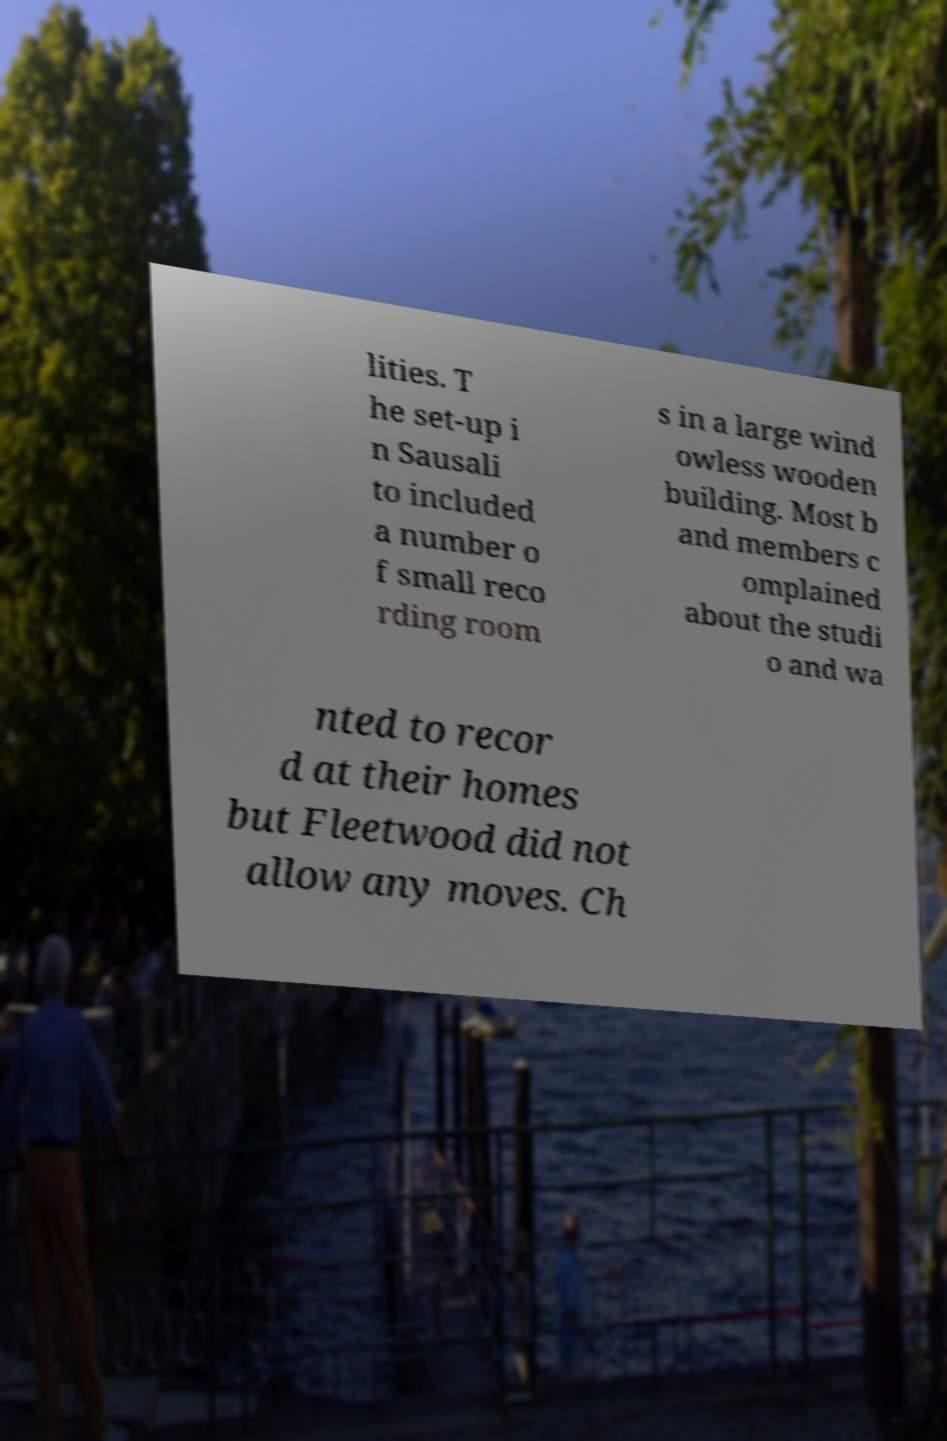I need the written content from this picture converted into text. Can you do that? lities. T he set-up i n Sausali to included a number o f small reco rding room s in a large wind owless wooden building. Most b and members c omplained about the studi o and wa nted to recor d at their homes but Fleetwood did not allow any moves. Ch 